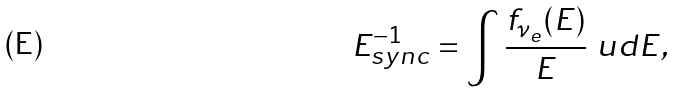<formula> <loc_0><loc_0><loc_500><loc_500>E _ { s y n c } ^ { - 1 } = \int \frac { f _ { \nu _ { e } } ( E ) } { E } \ u d E ,</formula> 